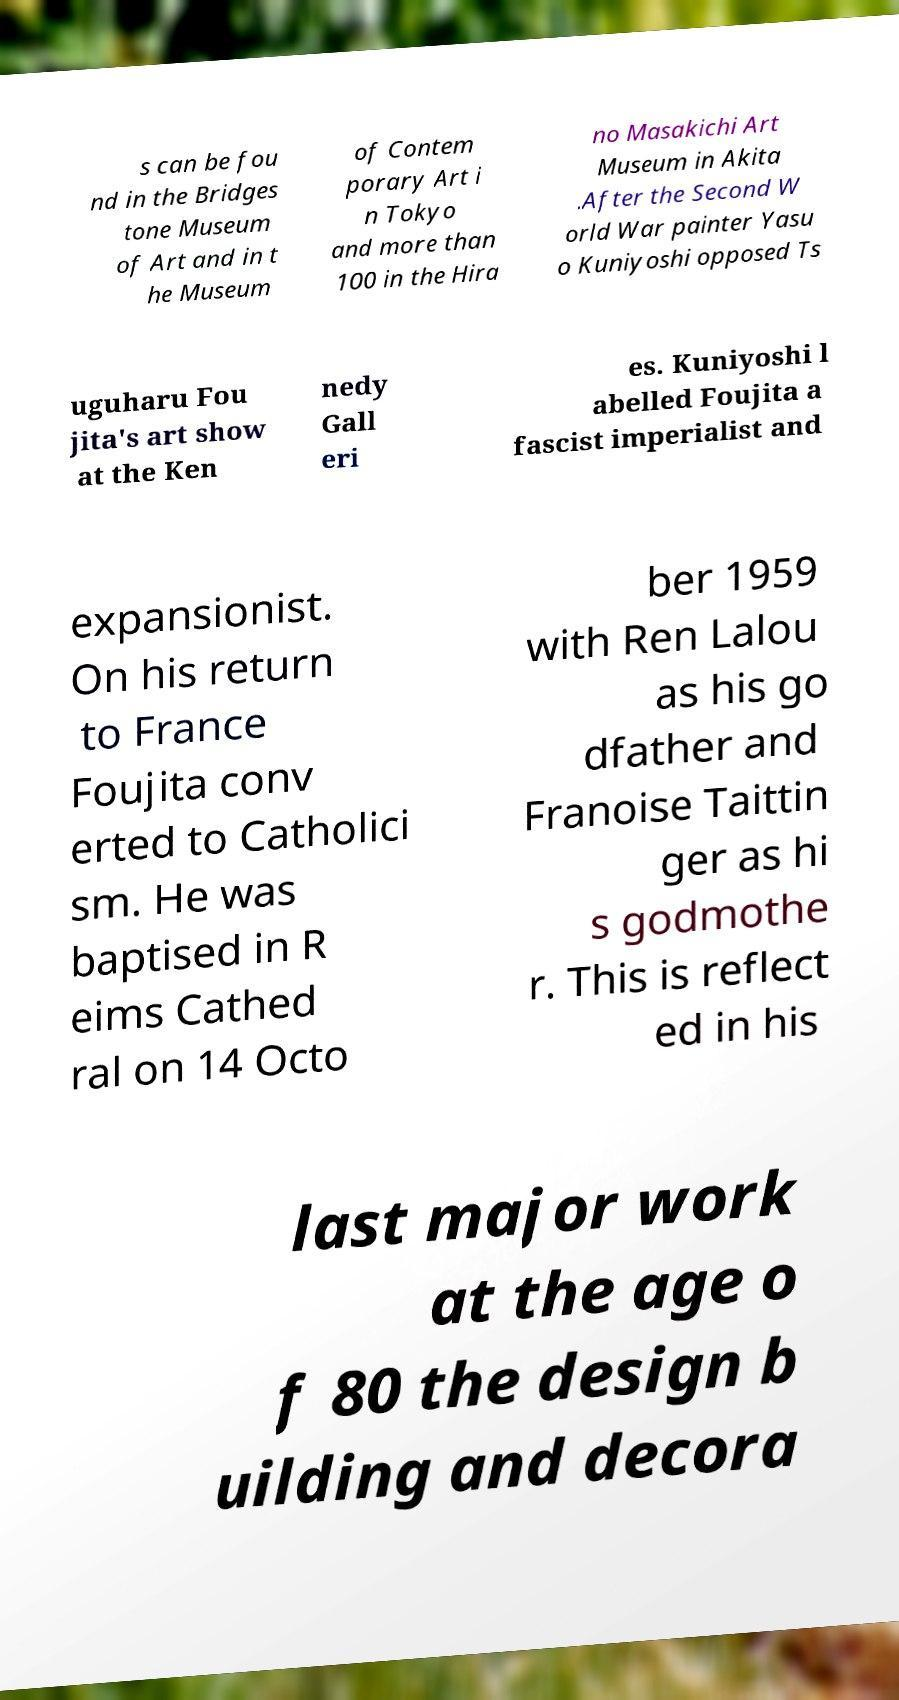Can you read and provide the text displayed in the image?This photo seems to have some interesting text. Can you extract and type it out for me? s can be fou nd in the Bridges tone Museum of Art and in t he Museum of Contem porary Art i n Tokyo and more than 100 in the Hira no Masakichi Art Museum in Akita .After the Second W orld War painter Yasu o Kuniyoshi opposed Ts uguharu Fou jita's art show at the Ken nedy Gall eri es. Kuniyoshi l abelled Foujita a fascist imperialist and expansionist. On his return to France Foujita conv erted to Catholici sm. He was baptised in R eims Cathed ral on 14 Octo ber 1959 with Ren Lalou as his go dfather and Franoise Taittin ger as hi s godmothe r. This is reflect ed in his last major work at the age o f 80 the design b uilding and decora 